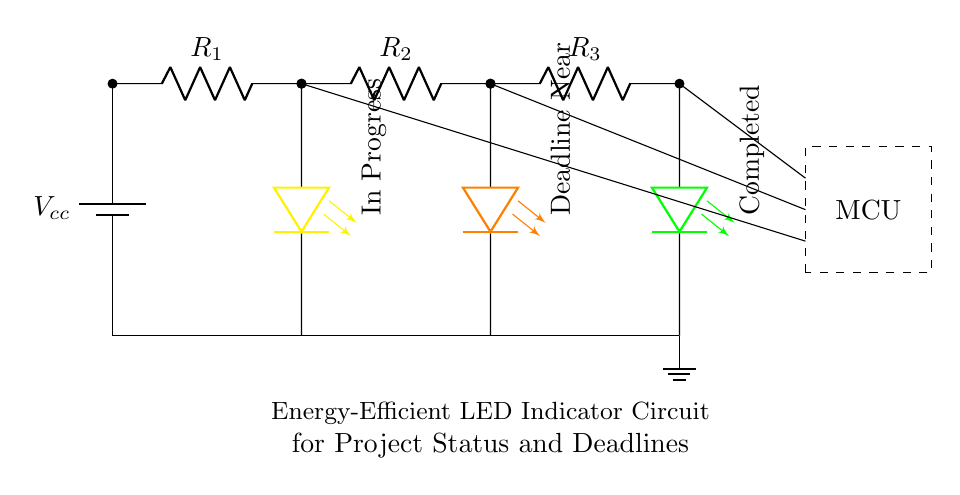What are the colors of the LEDs in this circuit? The circuit displays three LEDs with distinct colors: yellow for "In Progress," orange for "Deadline Near," and green for "Completed." These colors help indicate the different statuses of the project.
Answer: Yellow, orange, green How many resistors are there in the circuit? The circuit contains three resistors labeled R1, R2, and R3. Each resistor is connected between the voltage source and the respective LED, managing the current flow to protect the LEDs.
Answer: Three What does the dashed rectangle represent? The dashed rectangle in the circuit diagram symbolizes a microcontroller (MCU) that interfaces with the LEDs. It controls the status indications by switching the LEDs on and off based on the project states.
Answer: Microcontroller Which LED indicates a completed status? The green LED at the bottom of the circuit diagram corresponds to the "Completed" status. It visually signals that the project task has been finished, making it easy for users to identify progress.
Answer: Green What type of circuit is used in this design? This design is a low power appliance circuit focusing on energy efficiency, achieved using LEDs that consume less power compared to traditional indicators, minimizing overall energy usage.
Answer: Low power appliance What is the function of the resistors in this circuit? The resistors R1, R2, and R3 limit the current flowing through the LEDs to prevent them from drawing too much power which could lead to overheating or damage, ensuring safe operation of the circuit.
Answer: Current limiting 